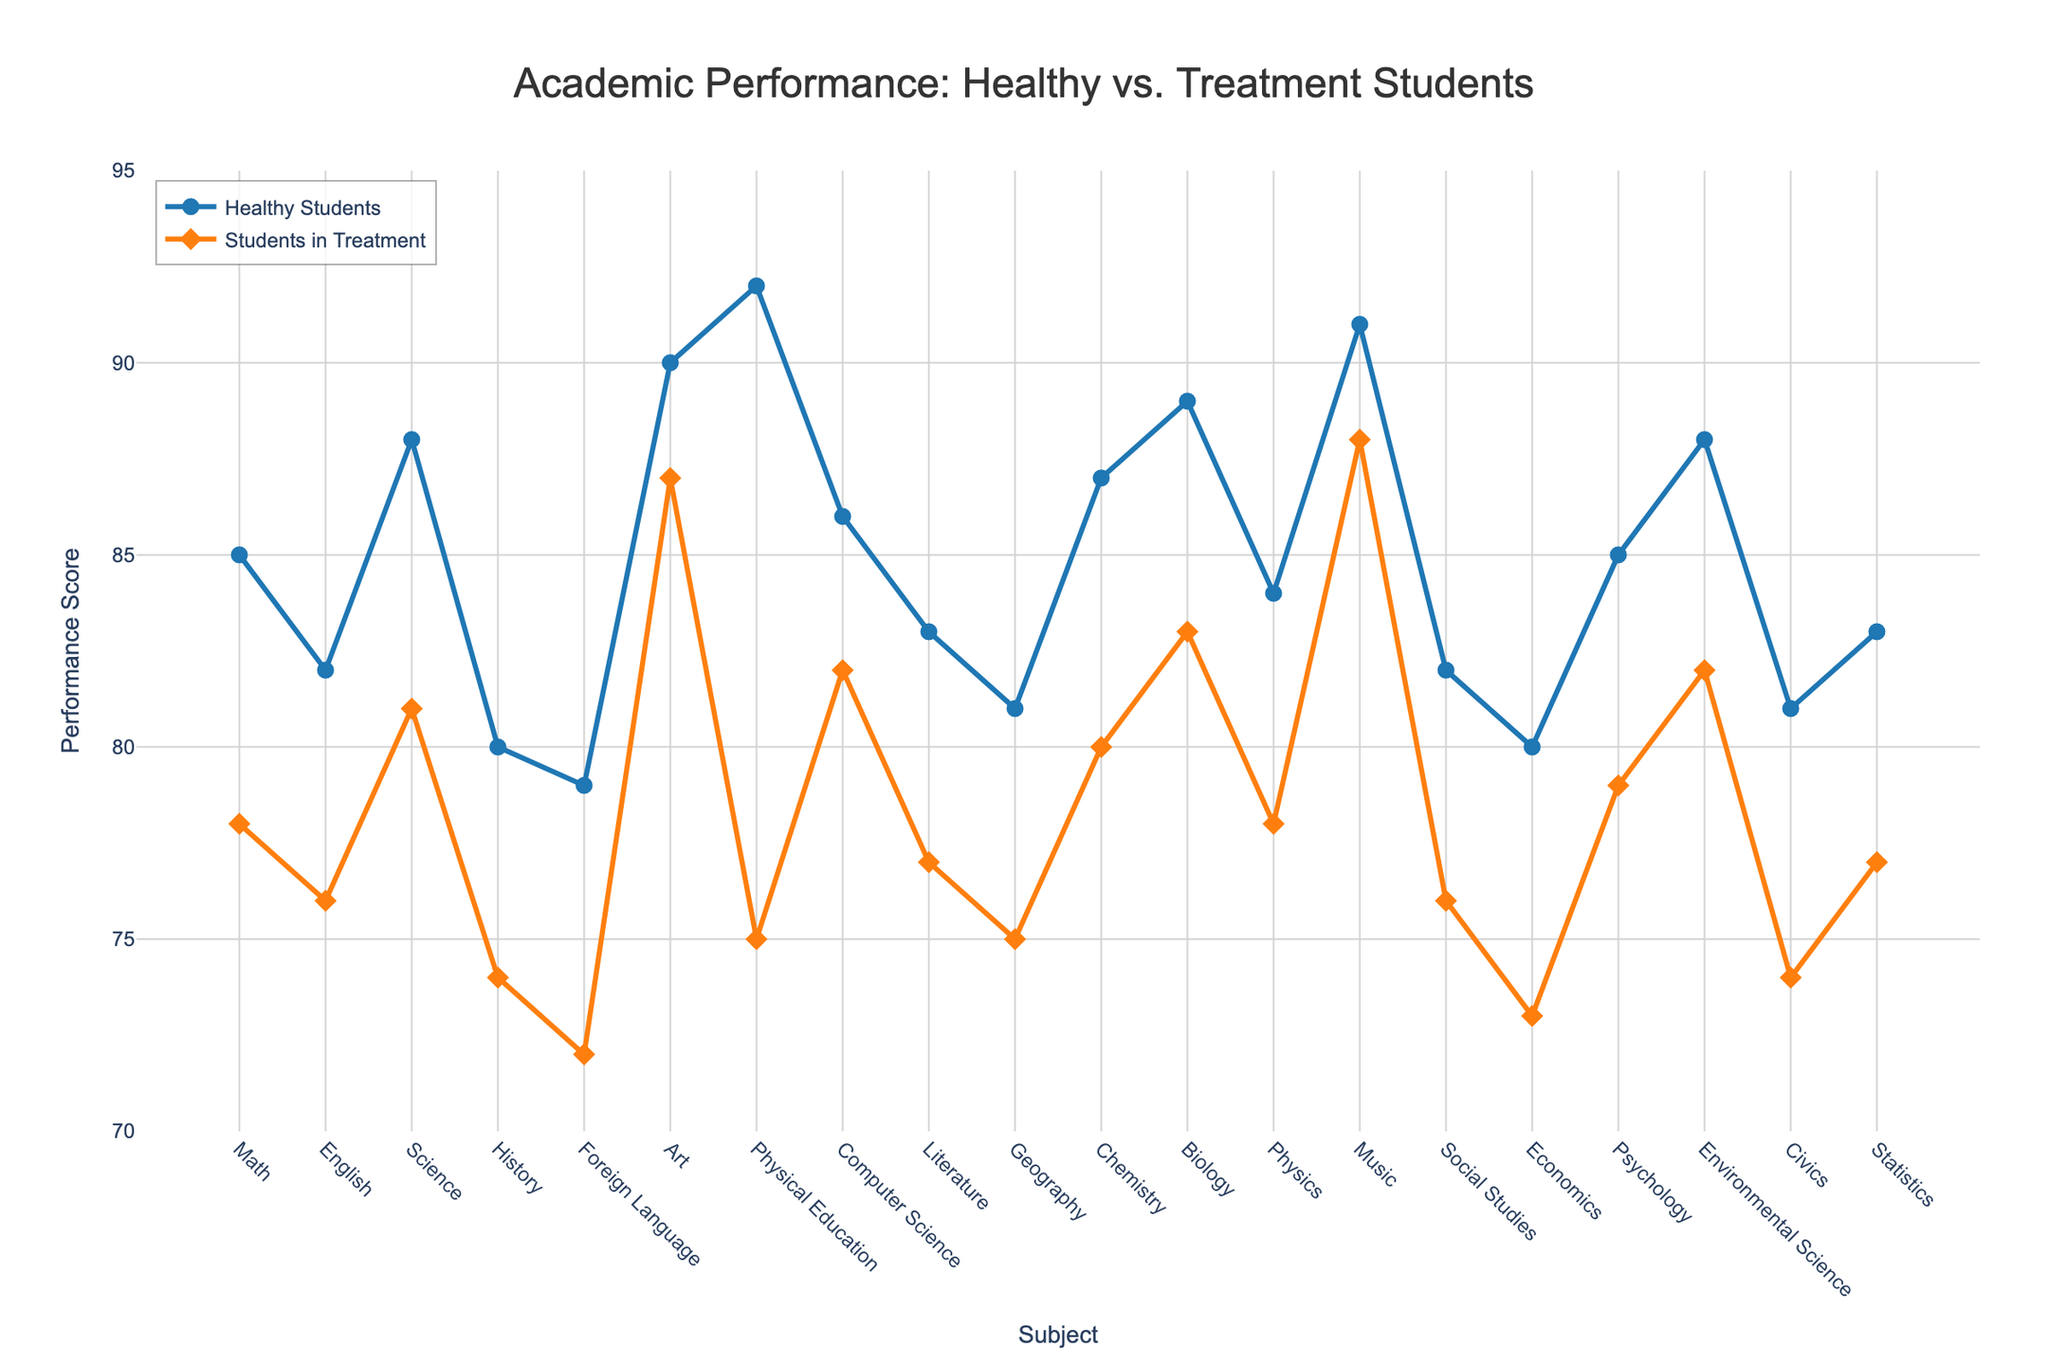What is the average performance score for Science subjects for Healthy Students and Students in Treatment? The Science subjects include Biology, Chemistry, Physics, and Environmental Science. For Healthy Students, the scores are [(89+87+84+88)/4], which averages to 87. For Students in Treatment, the scores are [(83+80+78+82)/4], which averages to 80.75
Answer: 87 for Healthy Students; 80.75 for Students in Treatment Which subject has the smallest gap in performance between Healthy Students and Students in Treatment? For each subject, subtract the performance score of Students in Treatment from the Healthy Students. Art has the smallest gap, with a difference of 3 (90 - 87).
Answer: Art What is the range of performance scores for Healthy Students? The range is found by subtracting the lowest score from the highest score among Healthy Students. The lowest score is 79 (Foreign Language), and the highest score is 92 (Physical Education). The range is 92 - 79.
Answer: 13 Identify the subject where the performance of Students in Treatment shows the greatest decline compared to their Healthy peers. To find the greatest decline, subtract the Students in Treatment score from the Healthy Students score and identify the maximum value. Physical Education shows the greatest decline of 17 points (92 - 75).
Answer: Physical Education Compare the performance in Literature between Healthy Students and Students in Treatment. Which group performs better, and by how much? Look at the scores for Literature: Healthy Students score 83, Students in Treatment score 77. Healthy Students perform better by 6 points (83 - 77).
Answer: Healthy Students; 6 points Which subject has equal or less than a 5-point performance difference between the two groups? Calculate the difference for each subject and identify those with a difference of 5 points or less. These subjects are English (6 points), Computer Science (4 points), and Psychology (6 points).
Answer: Computer Science (4 points) What is the sum of performance scores for Math and English for both groups? Add the scores of Math and English for Healthy Students and Students in Treatment:
Healthy Students: Math (85) + English (82) = 167; 
Students in Treatment: Math (78) + English (76) = 154
Answer: 167 for Healthy Students; 154 for Students in Treatment Compare the performance in Music between Healthy Students and Students in Treatment. By how much do Healthy Students perform better? Look at the scores for Music. Healthy Students score 91, and Students in Treatment score 88, so the difference is 91 - 88.
Answer: 3 points What is the average performance score for all subjects for Students in Treatment? Add up all scores for Students in Treatment and divide by the number of subjects. Total score = 78+76+81+74+72+87+75+82+77+75+80+83+78+88+76+73+79+82+74+77 = 1590. The total number of subjects is 20, so the average is 1590 / 20.
Answer: 79.5 